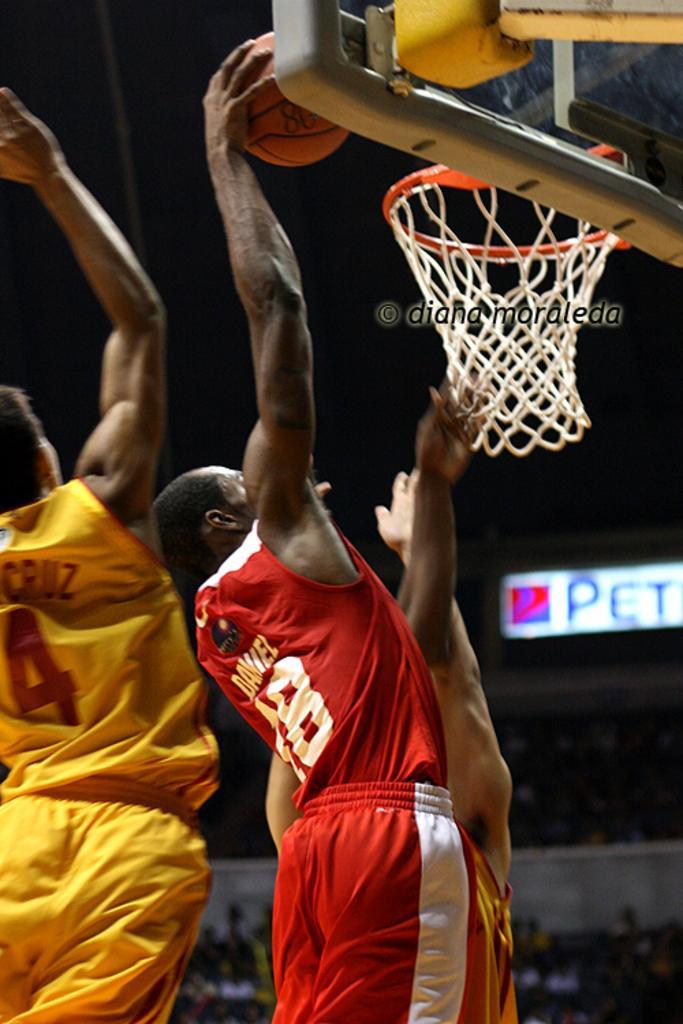Describe this image in one or two sentences. In the foreground of this picture, there are men in yellow and red color dresses playing basketball. We can also see a ball and the basket on the right top corner of the image. In the background, there are persons. 